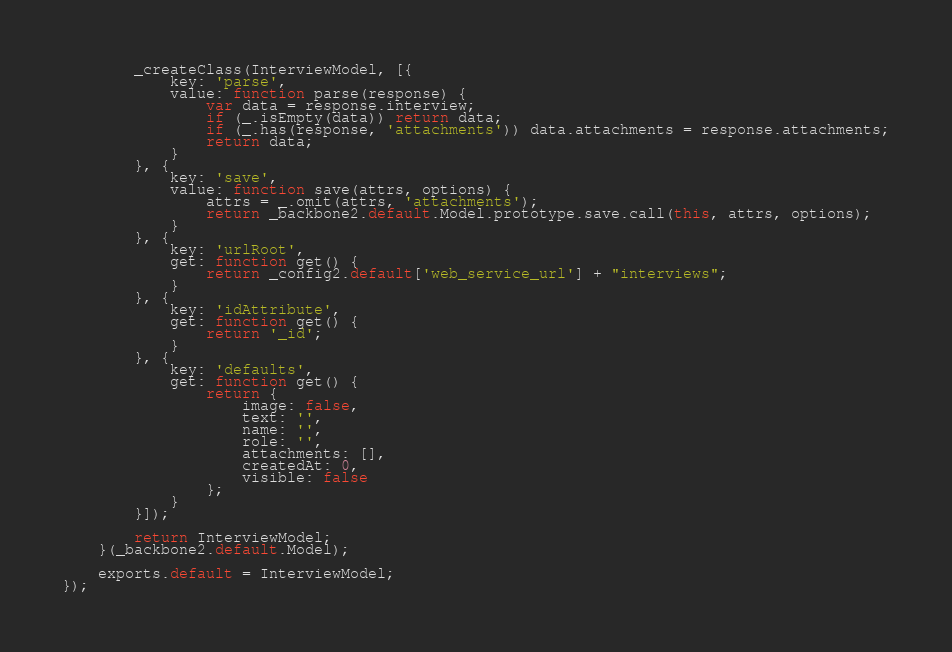Convert code to text. <code><loc_0><loc_0><loc_500><loc_500><_JavaScript_>		_createClass(InterviewModel, [{
			key: 'parse',
			value: function parse(response) {
				var data = response.interview;
				if (_.isEmpty(data)) return data;
				if (_.has(response, 'attachments')) data.attachments = response.attachments;
				return data;
			}
		}, {
			key: 'save',
			value: function save(attrs, options) {
				attrs = _.omit(attrs, 'attachments');
				return _backbone2.default.Model.prototype.save.call(this, attrs, options);
			}
		}, {
			key: 'urlRoot',
			get: function get() {
				return _config2.default['web_service_url'] + "interviews";
			}
		}, {
			key: 'idAttribute',
			get: function get() {
				return '_id';
			}
		}, {
			key: 'defaults',
			get: function get() {
				return {
					image: false,
					text: '',
					name: '',
					role: '',
					attachments: [],
					createdAt: 0,
					visible: false
				};
			}
		}]);

		return InterviewModel;
	}(_backbone2.default.Model);

	exports.default = InterviewModel;
});</code> 